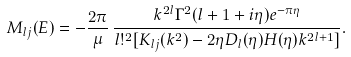Convert formula to latex. <formula><loc_0><loc_0><loc_500><loc_500>M _ { l j } ( E ) = - \frac { 2 \pi } { \mu } \, \frac { k ^ { 2 l } \Gamma ^ { 2 } ( l + 1 + i \eta ) e ^ { - \pi \eta } } { l ! ^ { 2 } [ K _ { l j } ( k ^ { 2 } ) - 2 \eta D _ { l } ( \eta ) H ( \eta ) k ^ { 2 l + 1 } ] } .</formula> 